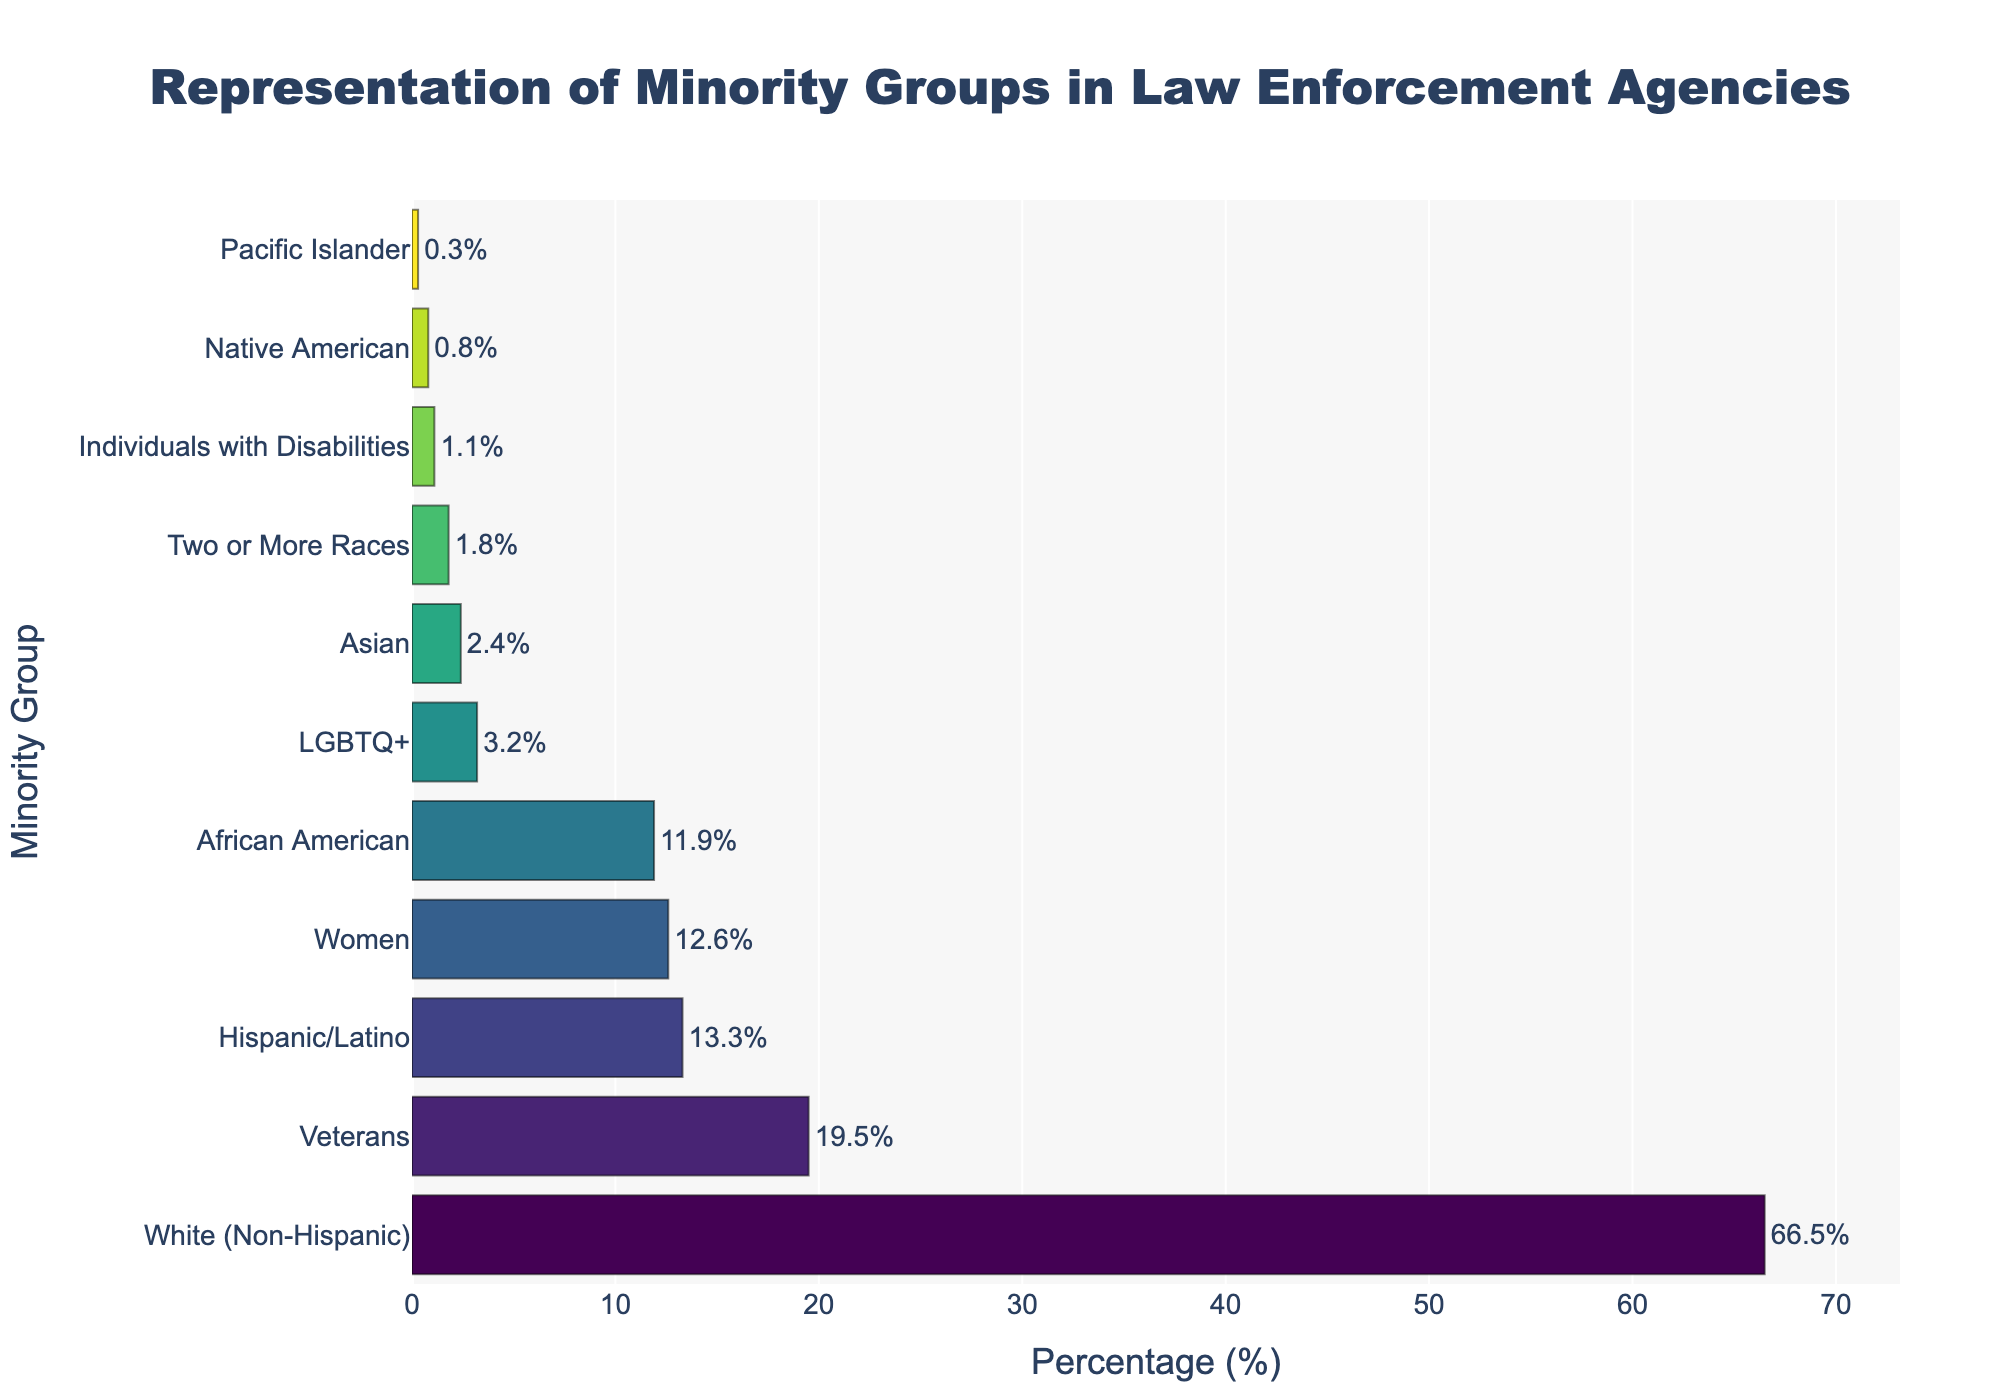What's the percentage of African American and Hispanic/Latino combined in law enforcement agencies? First, look at the figure and find the percentage for African American (11.9%) and for Hispanic/Latino (13.3%). Then, sum these two percentages: 11.9 + 13.3 = 25.2.
Answer: 25.2% Which group has a higher percentage, Veterans or Women? By how much? Find the bar representing Veterans (19.5%) and the bar representing Women (12.6%). Subtract the percentage of Women from Veterans: 19.5 - 12.6 = 6.9.
Answer: Veterans by 6.9% Which minority group has the lowest representation in law enforcement agencies? Look at the figure and identify the bar with the smallest length. The percentage for Pacific Islander is the lowest at 0.3%.
Answer: Pacific Islander How does the representation of LGBTQ+ compare to that of Individuals with Disabilities? Find the percentages for LGBTQ+ (3.2%) and for Individuals with Disabilities (1.1%). Notice that the percentage of LGBTQ+ is higher than that of Individuals with Disabilities.
Answer: LGBTQ+ has a higher percentage What is the difference in representation between the group with the highest percentage and the group with the lowest percentage? The group with the highest percentage is White (Non-Hispanic) at 66.5%, and the group with the lowest percentage is Pacific Islander at 0.3%. Subtract the latter from the former: 66.5 - 0.3 = 66.2.
Answer: 66.2 Which two groups combined have nearly the same representation as Veterans? Veterans have a representation of 19.5%. Look at other group percentages and find two that sum close to 19.5%. The percentages of Women (12.6%) and African American (11.9%) combined are 12.6 + 11.9 = 24.5, which is too high. However, African American (11.9%) and Hispanic/Latino (13.3%) combined are 11.9 + 13.3 = 25.2, which is still too high. Instead, the combined percentages of Two or More Races (1.8%) and White (Non-Hispanic) (66.5%) exceed 19.5%. Thus, no two groups closely match Veterans accurately. However, the combination closest to Veterans would involve groups with nearby sums like Women and LGBTQ+ or Individuals with Disabilities. The correct approach involves African American and Hispanic/Latino having the closest combined percentage to Veterans through recalculations.
Answer: African American and Hispanic/Latino How many groups are represented by less than 5% in law enforcement agencies? Look at the length of the bars representing percentages and count those below the 5% mark: Asian (2.4%), Native American (0.8%), Pacific Islander (0.3%), Two or More Races (1.8%), Individuals with Disabilities (1.1%), LGBTQ+ (3.2%). There are 6 groups.
Answer: 6 What is the average representation percentage of the three least represented groups? Identify the three least represented groups: Pacific Islander (0.3%), Native American (0.8%), and Individuals with Disabilities (1.1%). Calculate their average: (0.3 + 0.8 + 1.1) / 3 = 2.2 / 3 ≈ 0.73.
Answer: 0.73 Which group has a greater representation: Hispanic/Latino or Women, and by what percentage? Find the percentages for Hispanic/Latino (13.3%) and Women (12.6%). Subtract Women from Hispanic/Latino: 13.3 - 12.6 = 0.7.
Answer: Hispanic/Latino by 0.7 What percentage does the "White (Non-Hispanic)" group occupy out of the total minority groups combined (excluding "White (Non-Hispanic)" itself)? Exclude "White (Non-Hispanic)" and find the sum of all other groups' percentages. Excluding "White (Non-Hispanic)" which is 66.5%, the sum is 100 - 66.5 = 33.5. Verify by summing: African American (11.9), Hispanic/Latino (13.3), Asian (2.4), Native American (0.8), Pacific Islander (0.3), Two or More Races (1.8), Women (12.6), LGBTQ+ (3.2), Veterans (19.5), Individuals with Disabilities (1.1). The total is 68.9 and subtract from 100 confirms 33.5% excluding White (Non-Hispanic).
Answer: 66.5% 